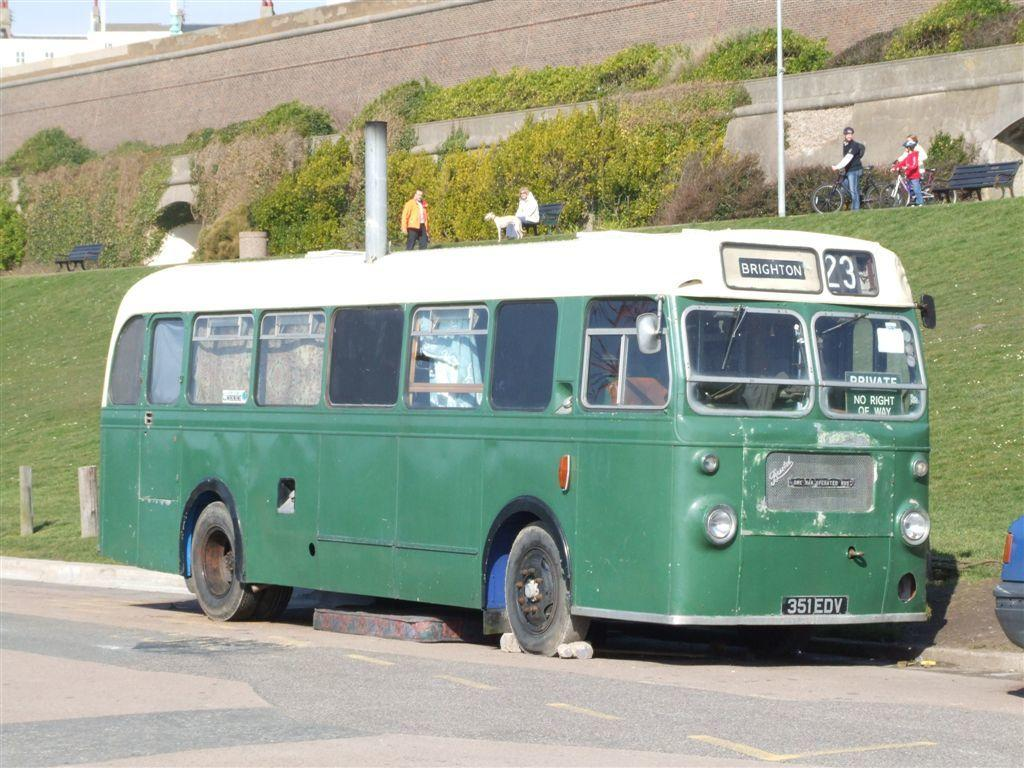<image>
Give a short and clear explanation of the subsequent image. The signage indicates the green bus is the number 23 going to Brighton. 